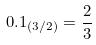<formula> <loc_0><loc_0><loc_500><loc_500>0 . 1 _ { ( 3 / 2 ) } = \frac { 2 } { 3 }</formula> 